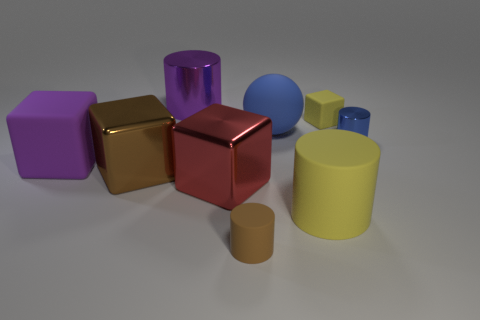Do the large yellow cylinder and the purple cube have the same material?
Your answer should be very brief. Yes. The other matte object that is the same shape as the small yellow thing is what color?
Provide a succinct answer. Purple. Does the large block left of the brown shiny object have the same color as the big metal cylinder?
Ensure brevity in your answer.  Yes. What shape is the large matte thing that is the same color as the small metal cylinder?
Your answer should be very brief. Sphere. How many blue objects are made of the same material as the blue cylinder?
Keep it short and to the point. 0. What number of tiny brown rubber cylinders are behind the brown matte cylinder?
Keep it short and to the point. 0. The brown metal cube is what size?
Offer a terse response. Large. What color is the metallic thing that is the same size as the yellow block?
Your answer should be very brief. Blue. Are there any small matte things of the same color as the large matte cylinder?
Give a very brief answer. Yes. What material is the brown block?
Provide a short and direct response. Metal. 